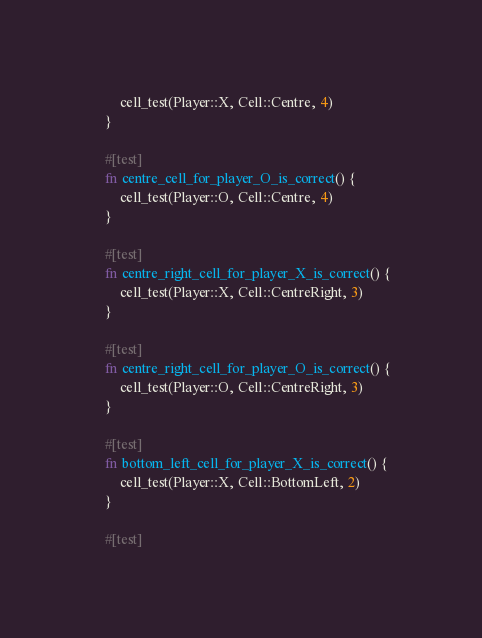<code> <loc_0><loc_0><loc_500><loc_500><_Rust_>        cell_test(Player::X, Cell::Centre, 4)
    }

    #[test]
    fn centre_cell_for_player_O_is_correct() {
        cell_test(Player::O, Cell::Centre, 4)
    }

    #[test]
    fn centre_right_cell_for_player_X_is_correct() {
        cell_test(Player::X, Cell::CentreRight, 3)
    }

    #[test]
    fn centre_right_cell_for_player_O_is_correct() {
        cell_test(Player::O, Cell::CentreRight, 3)
    }

    #[test]
    fn bottom_left_cell_for_player_X_is_correct() {
        cell_test(Player::X, Cell::BottomLeft, 2)
    }

    #[test]</code> 